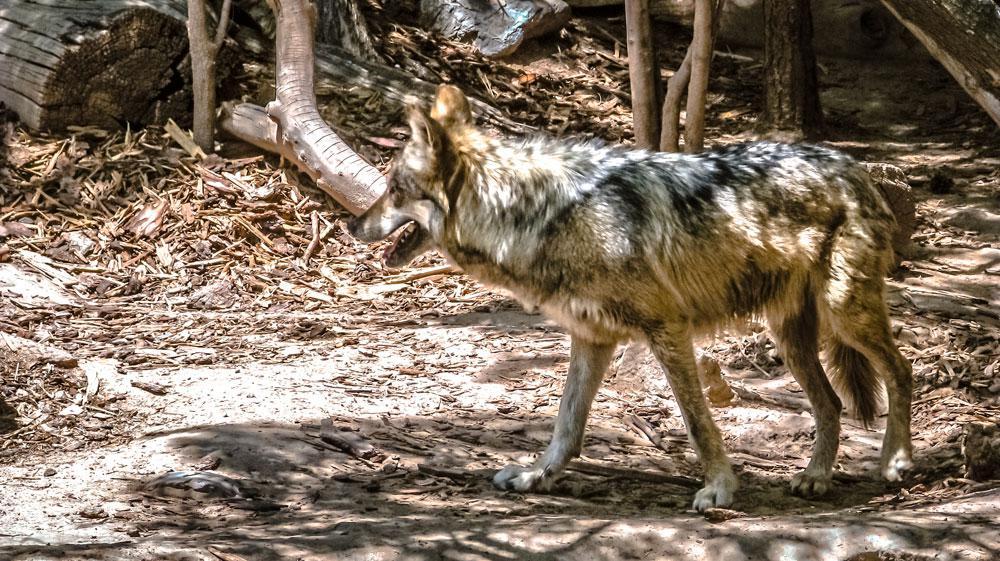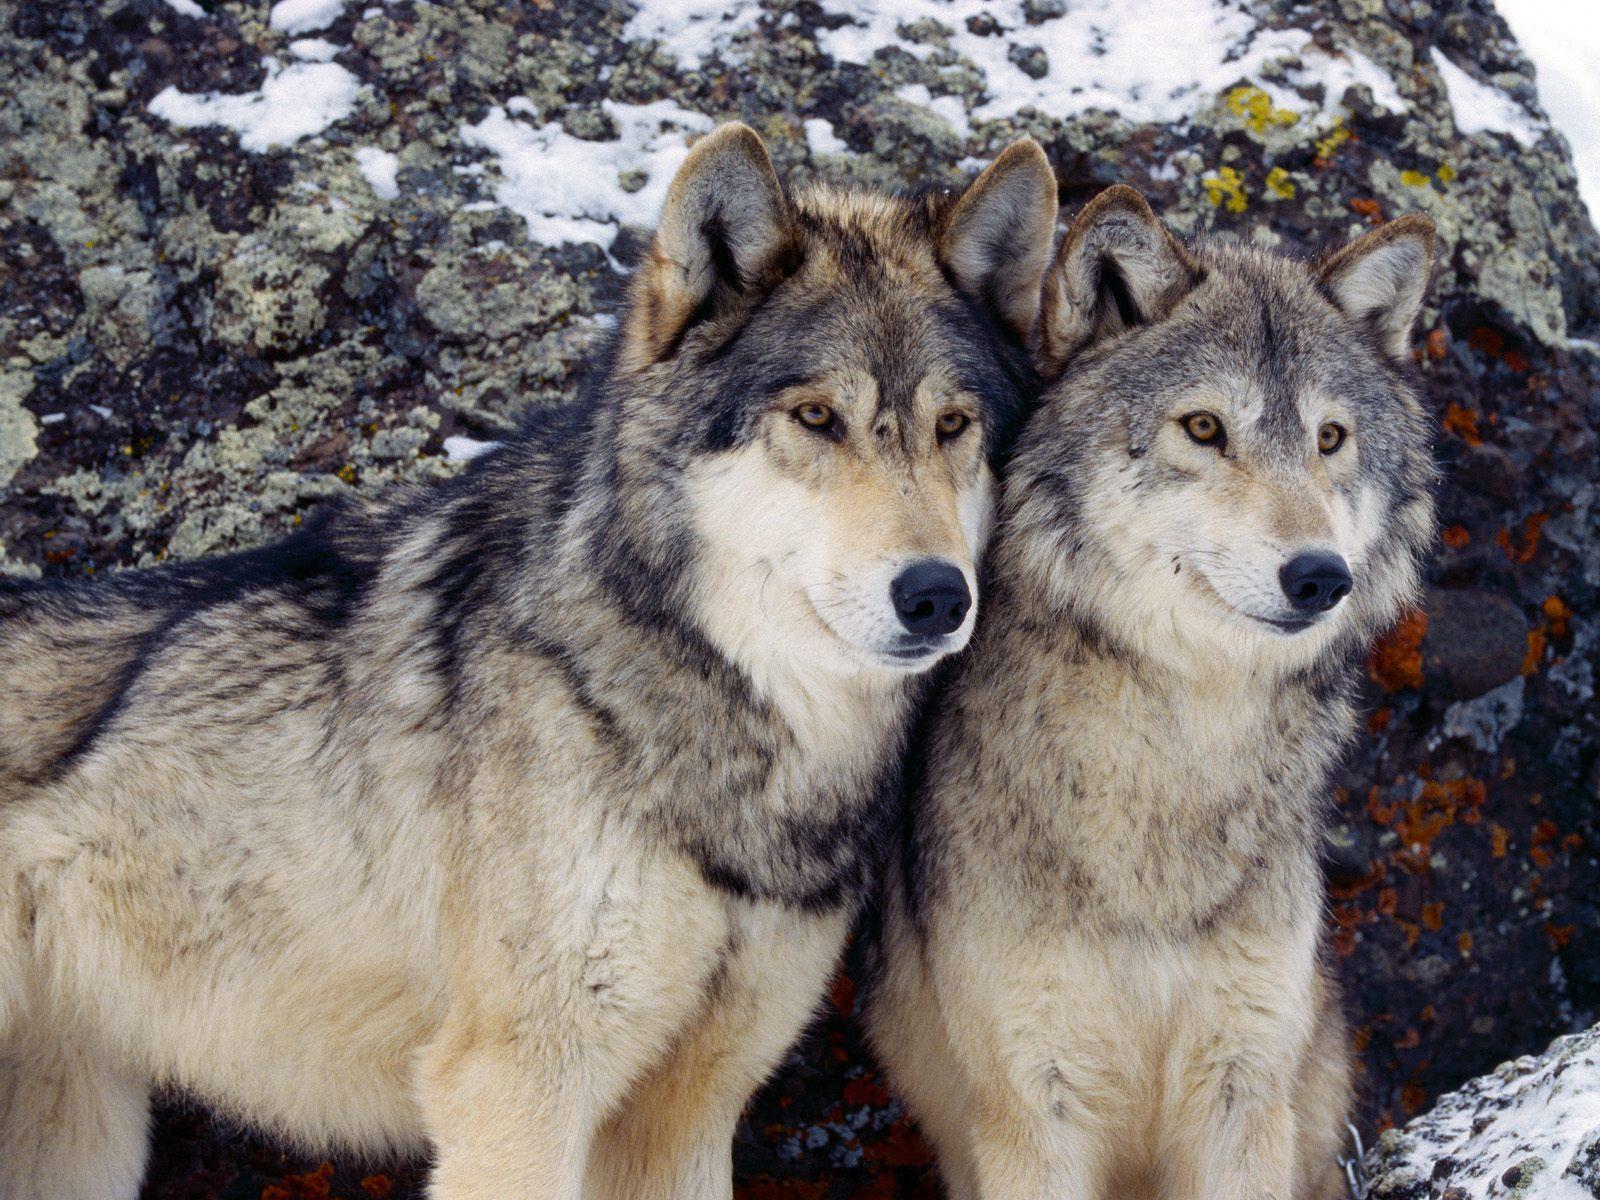The first image is the image on the left, the second image is the image on the right. For the images shown, is this caption "There are at least three wolves walking through heavy snow." true? Answer yes or no. No. The first image is the image on the left, the second image is the image on the right. For the images displayed, is the sentence "The left image contains a single standing wolf in a non-snowy setting, and the right image includes two wolves with their heads side-by-side in a scene with some snow." factually correct? Answer yes or no. Yes. 